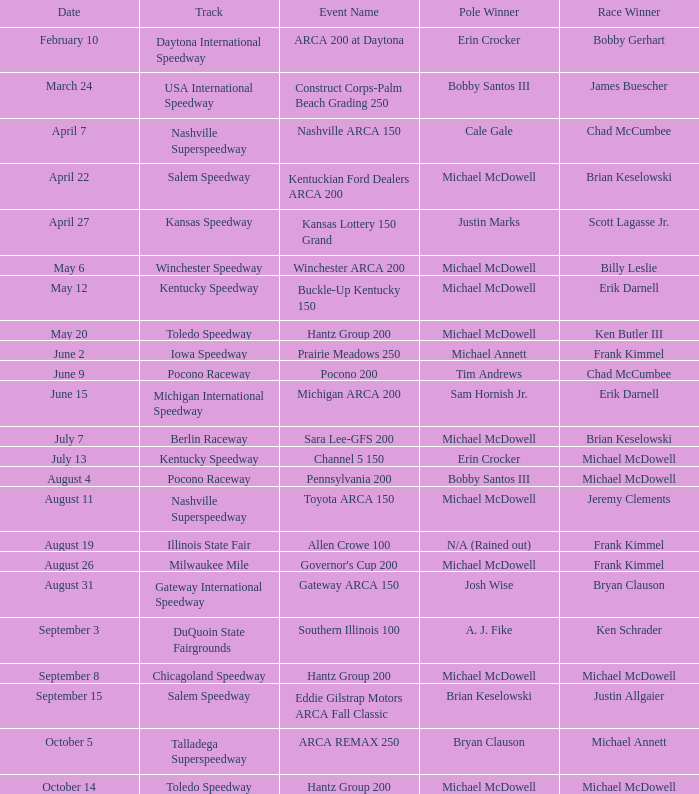Inform me of the pole victor on may 1 Michael McDowell. 